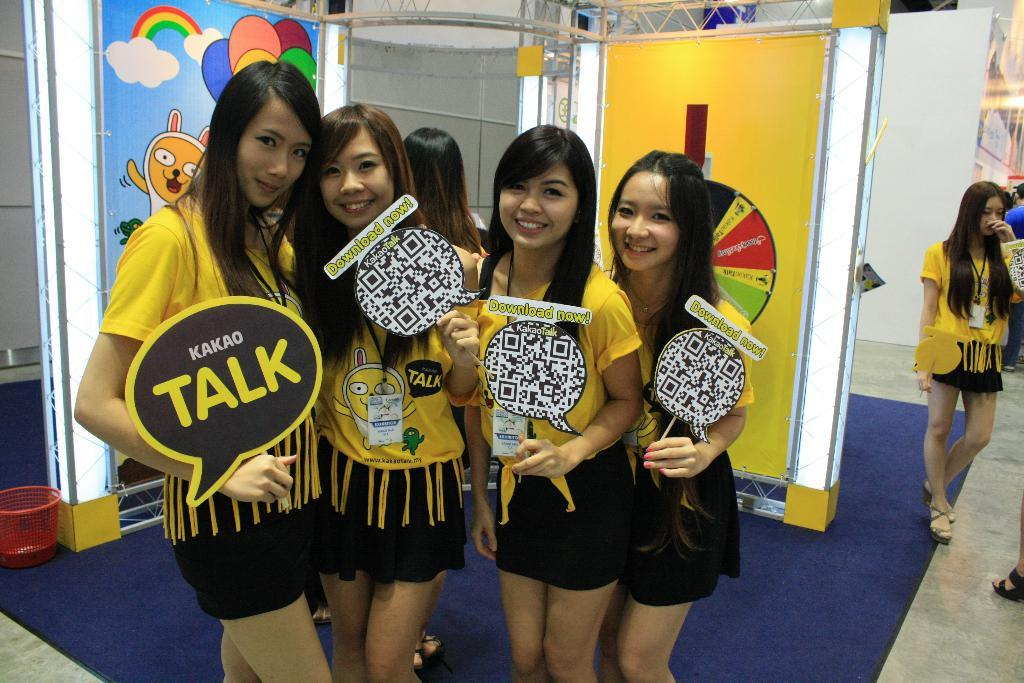<image>
Present a compact description of the photo's key features. Girls in yellow and black outfits holding a sign that has TALK in yellow letters. 